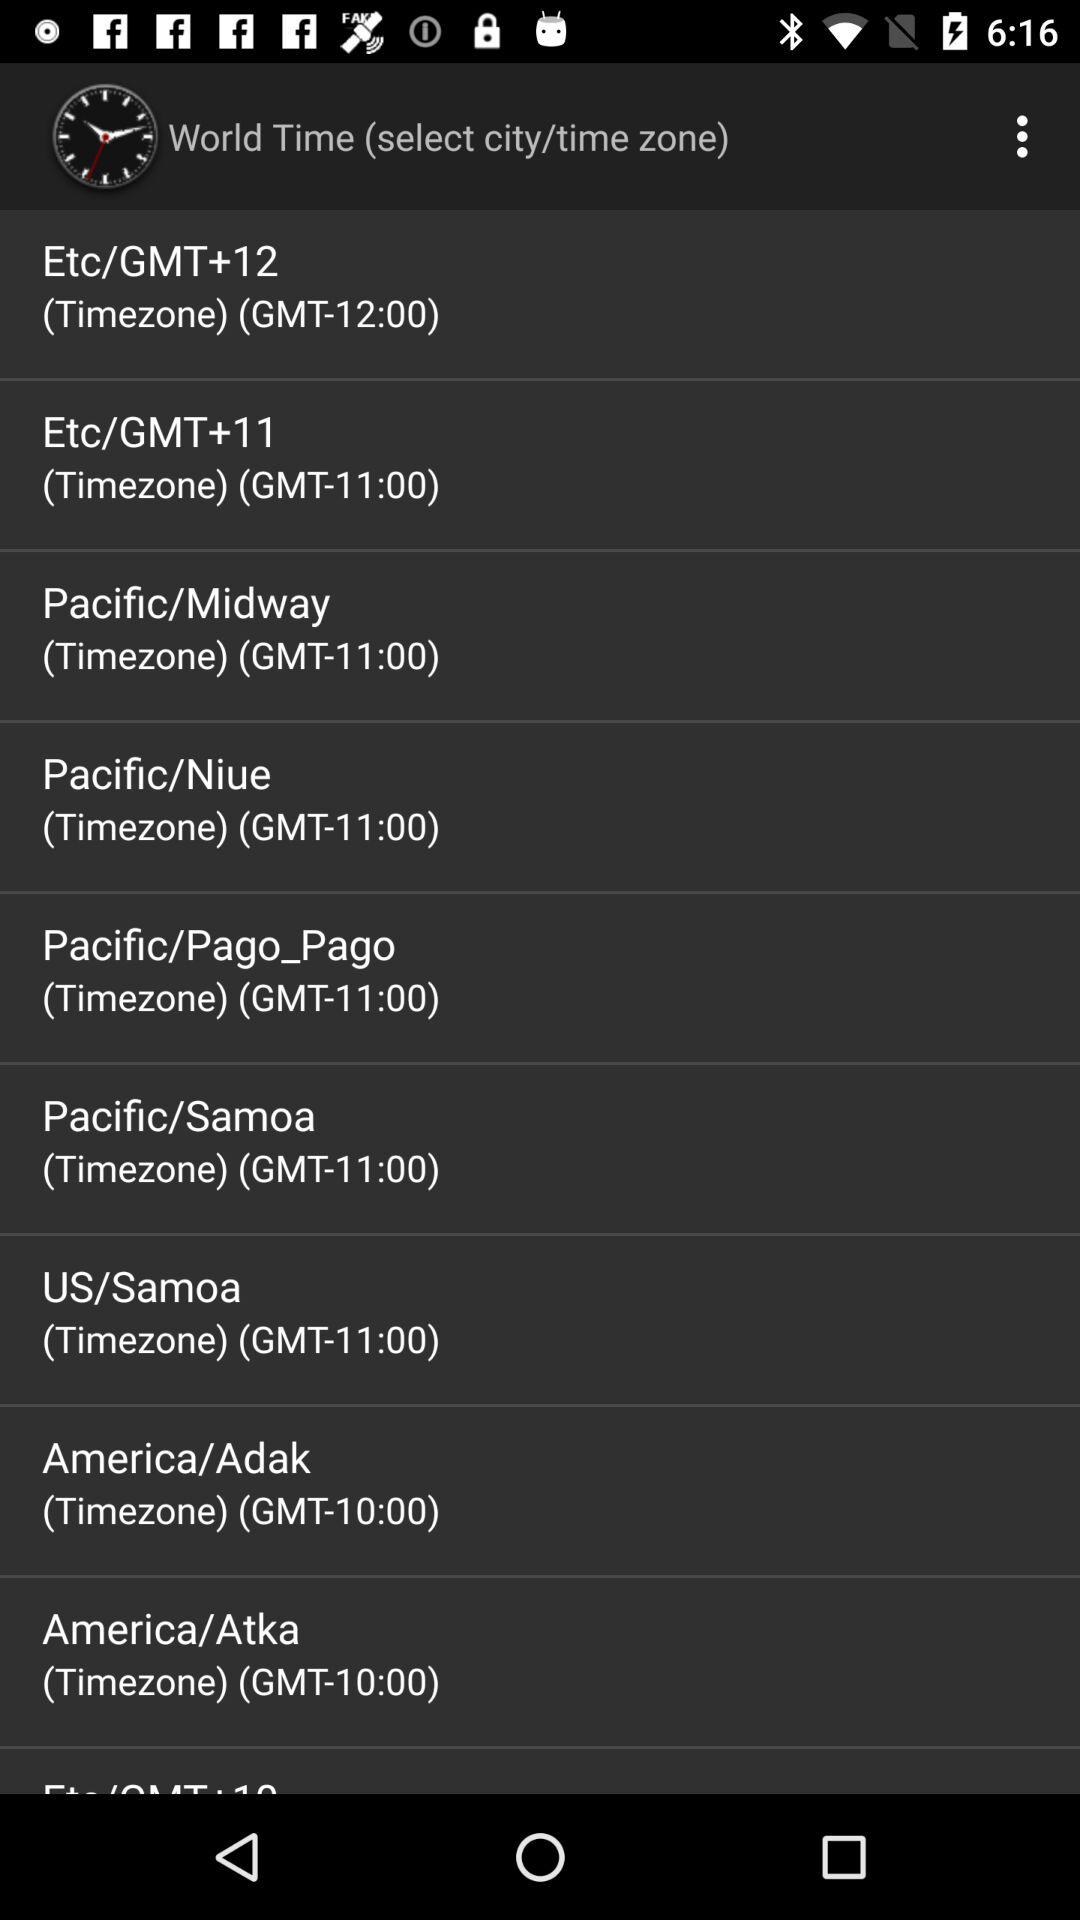What is the time zone of America/Adak? The time zone of America/Adak is GMT-10:00. 